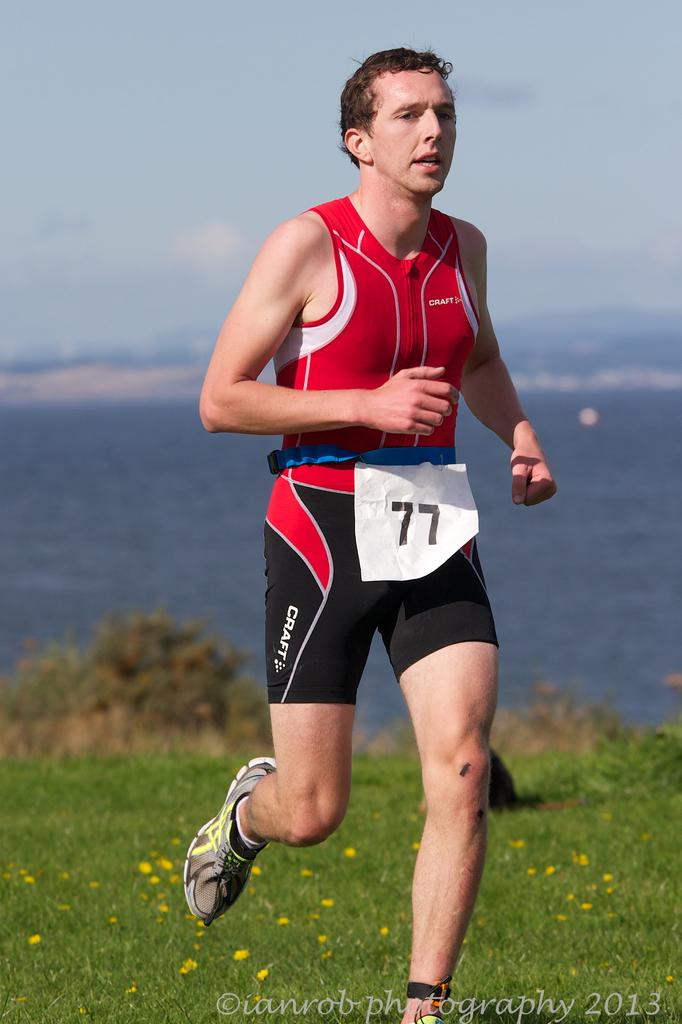<image>
Give a short and clear explanation of the subsequent image. A runner is wearing a Craft outfit and the number 77. 